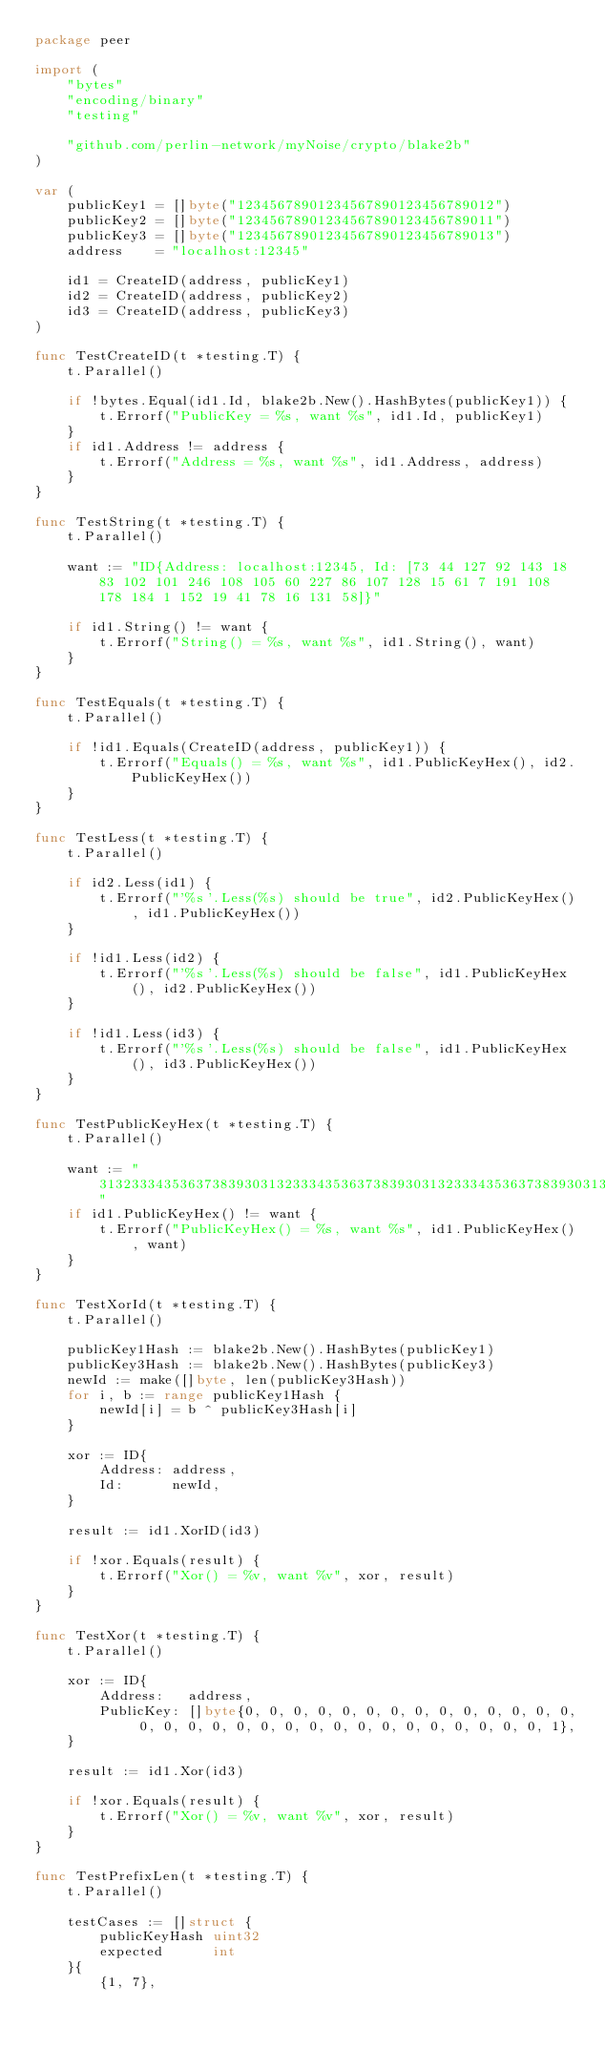<code> <loc_0><loc_0><loc_500><loc_500><_Go_>package peer

import (
	"bytes"
	"encoding/binary"
	"testing"

	"github.com/perlin-network/myNoise/crypto/blake2b"
)

var (
	publicKey1 = []byte("12345678901234567890123456789012")
	publicKey2 = []byte("12345678901234567890123456789011")
	publicKey3 = []byte("12345678901234567890123456789013")
	address    = "localhost:12345"

	id1 = CreateID(address, publicKey1)
	id2 = CreateID(address, publicKey2)
	id3 = CreateID(address, publicKey3)
)

func TestCreateID(t *testing.T) {
	t.Parallel()

	if !bytes.Equal(id1.Id, blake2b.New().HashBytes(publicKey1)) {
		t.Errorf("PublicKey = %s, want %s", id1.Id, publicKey1)
	}
	if id1.Address != address {
		t.Errorf("Address = %s, want %s", id1.Address, address)
	}
}

func TestString(t *testing.T) {
	t.Parallel()

	want := "ID{Address: localhost:12345, Id: [73 44 127 92 143 18 83 102 101 246 108 105 60 227 86 107 128 15 61 7 191 108 178 184 1 152 19 41 78 16 131 58]}"

	if id1.String() != want {
		t.Errorf("String() = %s, want %s", id1.String(), want)
	}
}

func TestEquals(t *testing.T) {
	t.Parallel()

	if !id1.Equals(CreateID(address, publicKey1)) {
		t.Errorf("Equals() = %s, want %s", id1.PublicKeyHex(), id2.PublicKeyHex())
	}
}

func TestLess(t *testing.T) {
	t.Parallel()

	if id2.Less(id1) {
		t.Errorf("'%s'.Less(%s) should be true", id2.PublicKeyHex(), id1.PublicKeyHex())
	}

	if !id1.Less(id2) {
		t.Errorf("'%s'.Less(%s) should be false", id1.PublicKeyHex(), id2.PublicKeyHex())
	}

	if !id1.Less(id3) {
		t.Errorf("'%s'.Less(%s) should be false", id1.PublicKeyHex(), id3.PublicKeyHex())
	}
}

func TestPublicKeyHex(t *testing.T) {
	t.Parallel()

	want := "3132333435363738393031323334353637383930313233343536373839303132"
	if id1.PublicKeyHex() != want {
		t.Errorf("PublicKeyHex() = %s, want %s", id1.PublicKeyHex(), want)
	}
}

func TestXorId(t *testing.T) {
	t.Parallel()

	publicKey1Hash := blake2b.New().HashBytes(publicKey1)
	publicKey3Hash := blake2b.New().HashBytes(publicKey3)
	newId := make([]byte, len(publicKey3Hash))
	for i, b := range publicKey1Hash {
		newId[i] = b ^ publicKey3Hash[i]
	}

	xor := ID{
		Address: address,
		Id:      newId,
	}

	result := id1.XorID(id3)

	if !xor.Equals(result) {
		t.Errorf("Xor() = %v, want %v", xor, result)
	}
}

func TestXor(t *testing.T) {
	t.Parallel()

	xor := ID{
		Address:   address,
		PublicKey: []byte{0, 0, 0, 0, 0, 0, 0, 0, 0, 0, 0, 0, 0, 0, 0, 0, 0, 0, 0, 0, 0, 0, 0, 0, 0, 0, 0, 0, 0, 0, 0, 1},
	}

	result := id1.Xor(id3)

	if !xor.Equals(result) {
		t.Errorf("Xor() = %v, want %v", xor, result)
	}
}

func TestPrefixLen(t *testing.T) {
	t.Parallel()

	testCases := []struct {
		publicKeyHash uint32
		expected      int
	}{
		{1, 7},</code> 